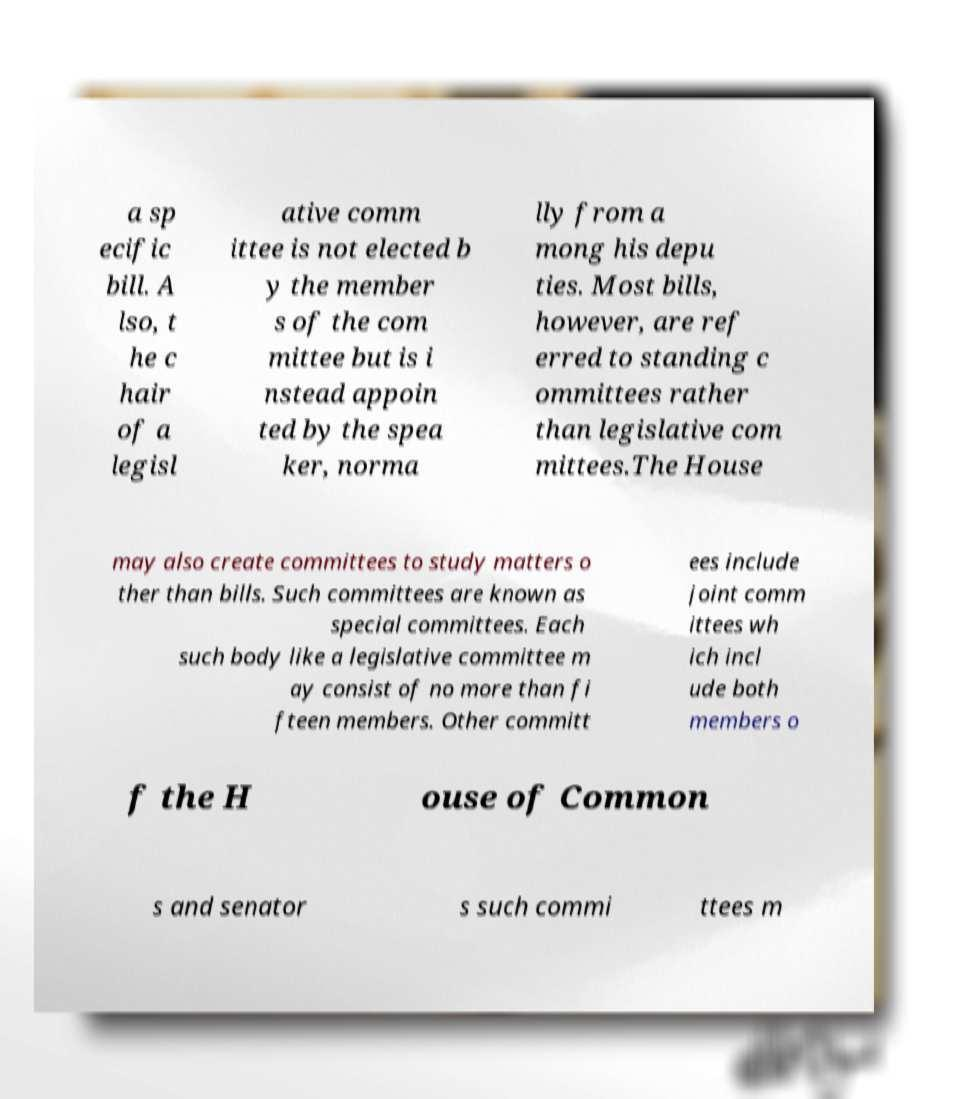I need the written content from this picture converted into text. Can you do that? a sp ecific bill. A lso, t he c hair of a legisl ative comm ittee is not elected b y the member s of the com mittee but is i nstead appoin ted by the spea ker, norma lly from a mong his depu ties. Most bills, however, are ref erred to standing c ommittees rather than legislative com mittees.The House may also create committees to study matters o ther than bills. Such committees are known as special committees. Each such body like a legislative committee m ay consist of no more than fi fteen members. Other committ ees include joint comm ittees wh ich incl ude both members o f the H ouse of Common s and senator s such commi ttees m 